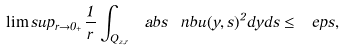<formula> <loc_0><loc_0><loc_500><loc_500>\lim s u p _ { r \to 0 _ { + } } \frac { 1 } { r } \int _ { Q _ { z , r } } \ a b s { \ n b u ( y , s ) } ^ { 2 } d y d s \leq \ e p s ,</formula> 